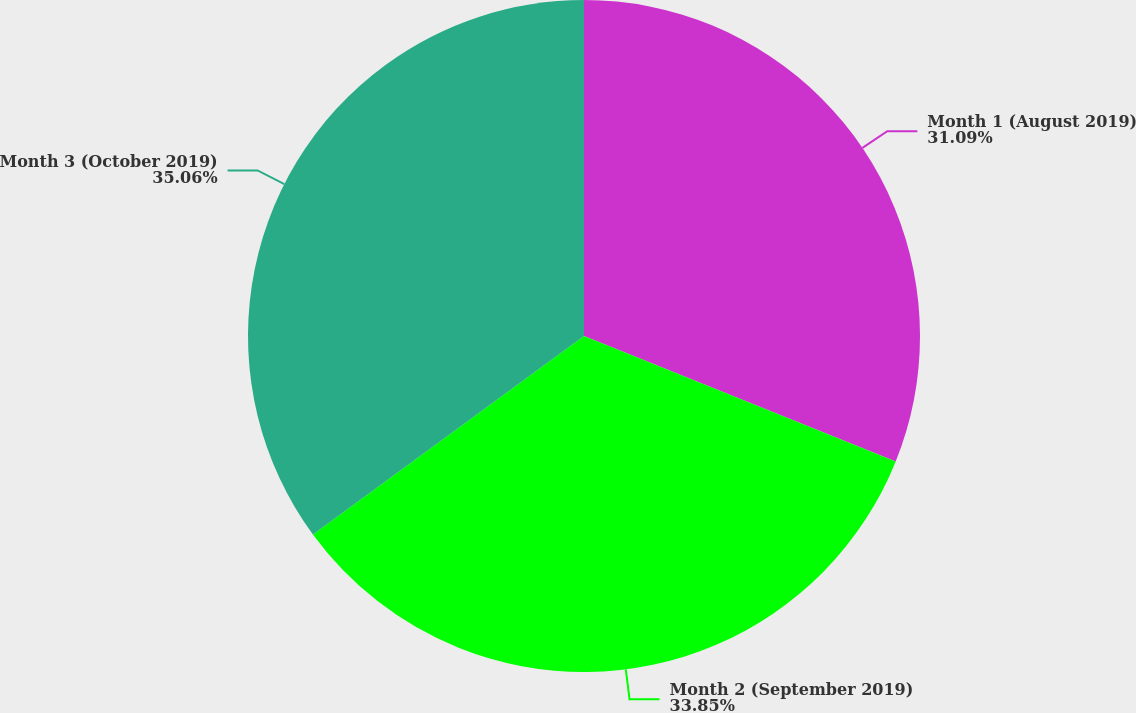Convert chart. <chart><loc_0><loc_0><loc_500><loc_500><pie_chart><fcel>Month 1 (August 2019)<fcel>Month 2 (September 2019)<fcel>Month 3 (October 2019)<nl><fcel>31.09%<fcel>33.85%<fcel>35.06%<nl></chart> 